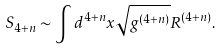<formula> <loc_0><loc_0><loc_500><loc_500>S _ { 4 + n } \sim \int d ^ { 4 + n } x \sqrt { g ^ { ( 4 + n ) } } R ^ { ( 4 + n ) } .</formula> 